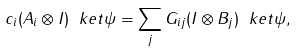<formula> <loc_0><loc_0><loc_500><loc_500>c _ { i } ( A _ { i } \otimes I ) \ k e t { \psi } = \sum _ { j } G _ { i j } ( I \otimes B _ { j } ) \ k e t { \psi } ,</formula> 